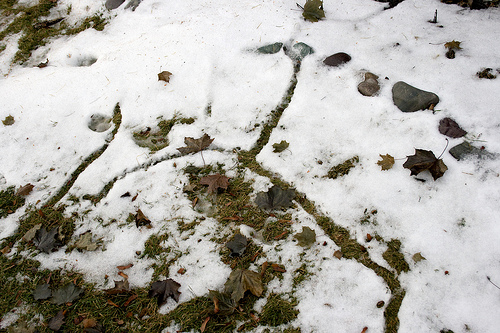<image>
Is there a leaf above the snow? No. The leaf is not positioned above the snow. The vertical arrangement shows a different relationship. 